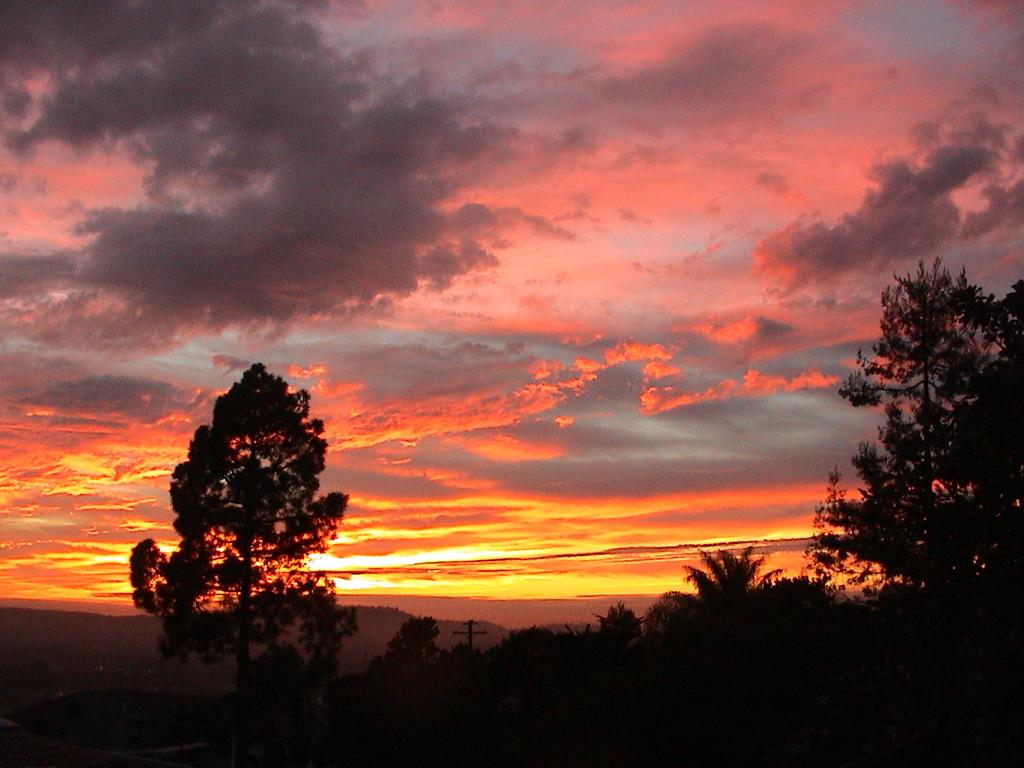What type of vegetation can be seen in the image? There are trees in the image. What structure is present in the image? There is a pole in the image. How would you describe the weather in the image? The sky is cloudy in the image, which suggests a partly cloudy or overcast day. Can you see any natural light in the image? Yes, sunlight is visible in the image. What color is the scarf hanging on the door in the image? There is no door or scarf present in the image; it only features trees, a pole, and the sky. 